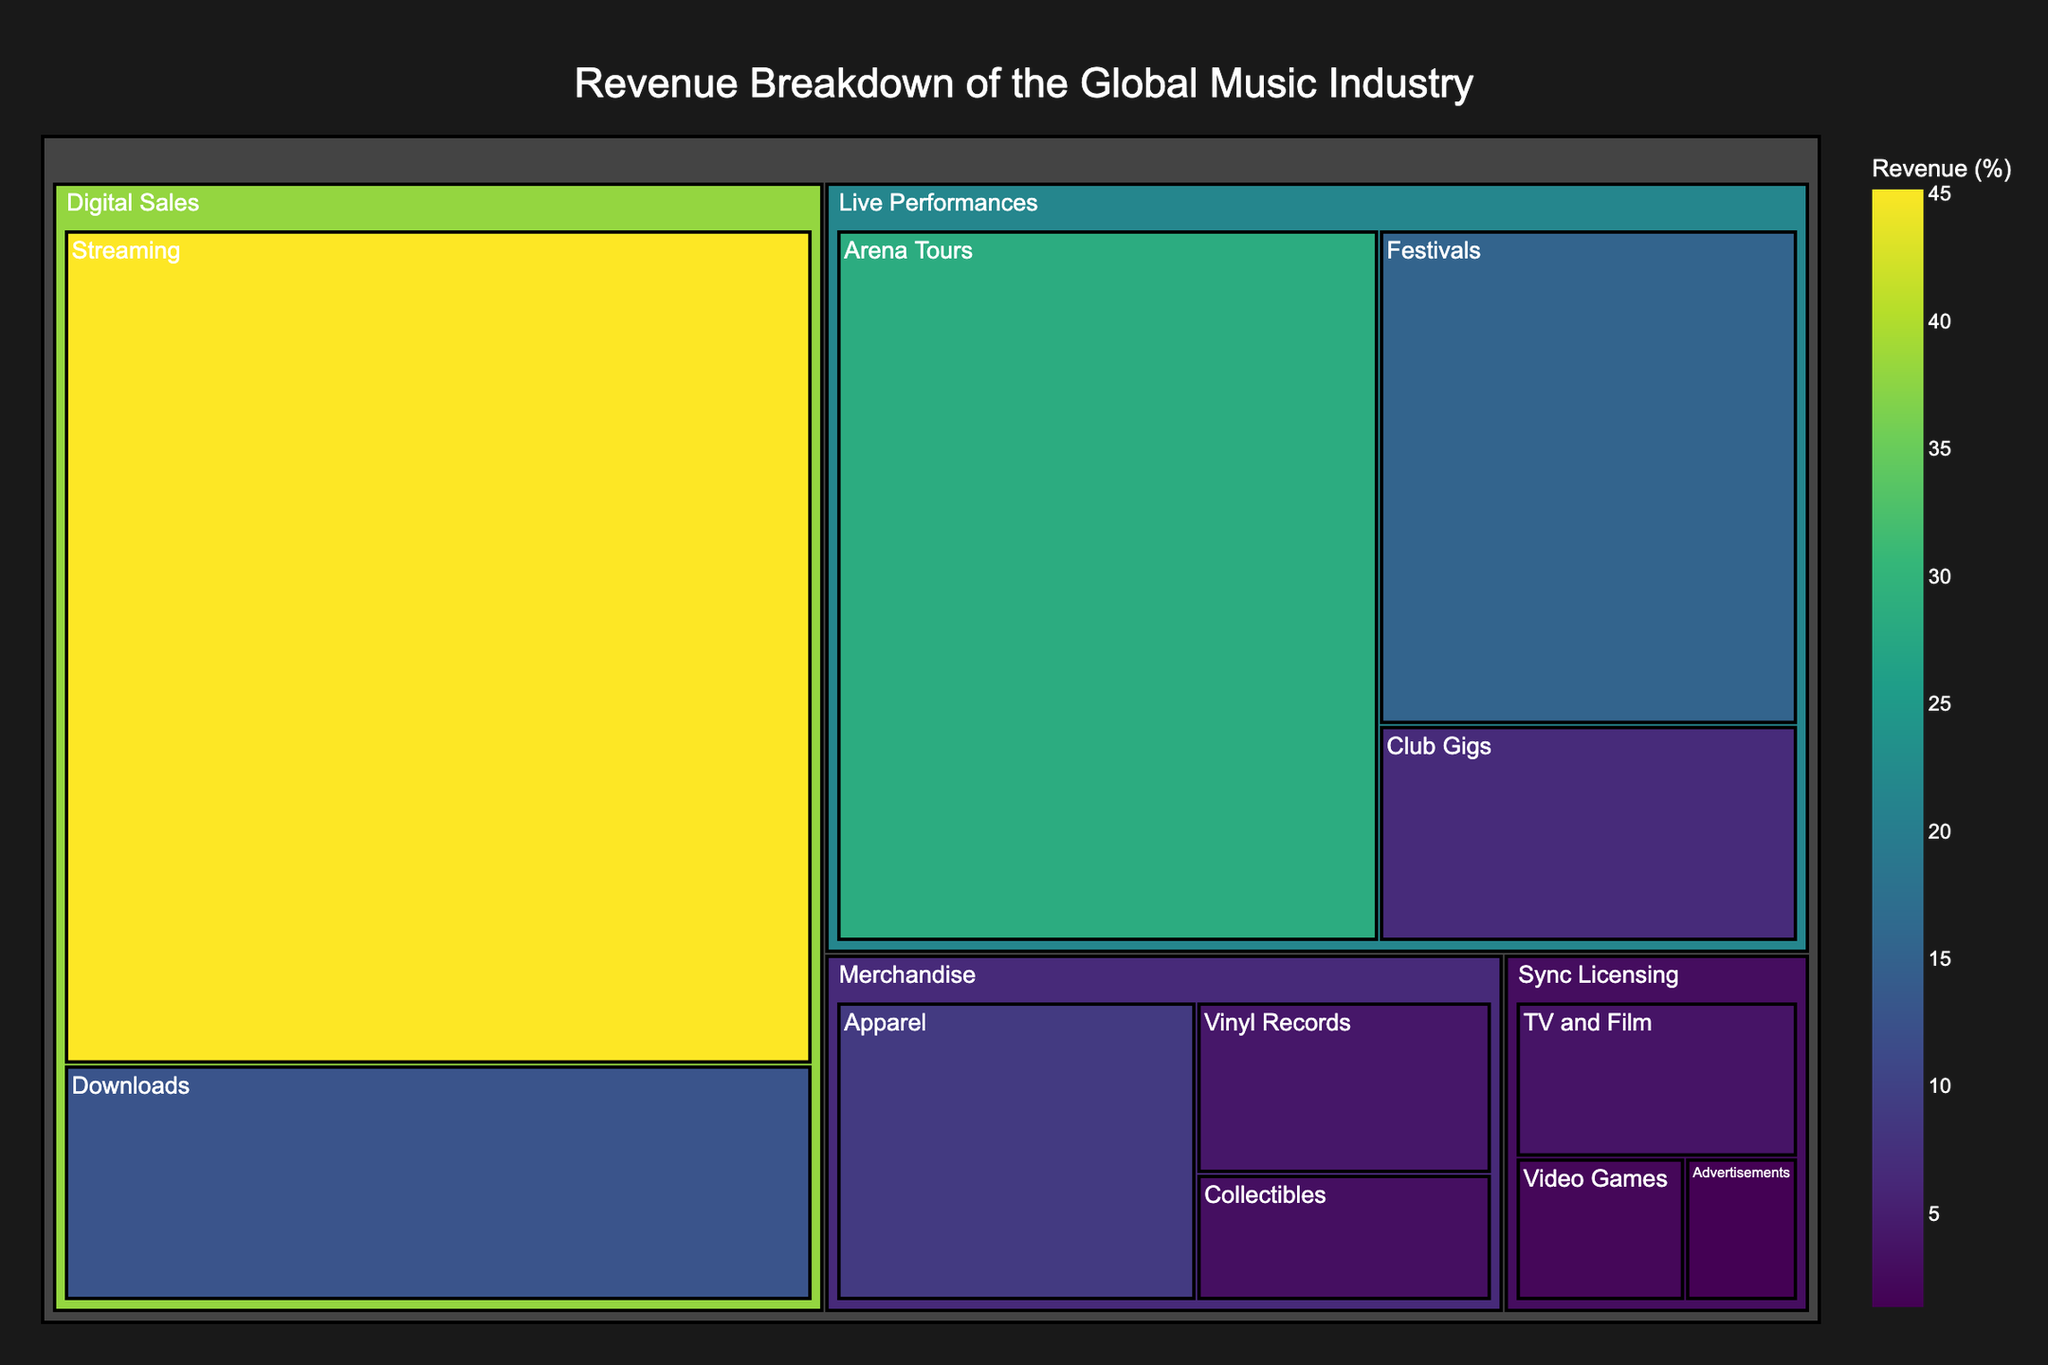what is the largest subcategory in terms of value? The largest subcategory in terms of value can be identified by looking at the size of the sections within the treemap. The section labeled "Streaming" under "Digital Sales" appears to be the largest.
Answer: Streaming what is the total value of the Live Performances category? To find the total value of the Live Performances category, sum the values of the subcategories: Arena Tours (28.5), Festivals (15.3), and Club Gigs (6.7). The calculation is 28.5 + 15.3 + 6.7 = 50.5.
Answer: 50.5 Which is greater: the value of Digital Sales or Live Performances? To determine which is greater, sum the values of the subcategories for each category. Digital Sales has 45.2 (Streaming) + 12.8 (Downloads) = 58. Live Performances has 28.5 (Arena Tours) + 15.3 (Festivals) + 6.7 (Club Gigs) = 50.5. Since 58 > 50.5, Digital Sales is greater.
Answer: Digital Sales What is the difference in value between the largest and smallest subcategories? To find the difference, identify the largest subcategory (Streaming at 45.2) and the smallest subcategory (Advertisements at 1.4), then subtract the smallest from the largest: 45.2 - 1.4 = 43.8.
Answer: 43.8 How does the value of Apparel in Merchandise compare with the value of Arena Tours in Live Performances? Compare the values of these subcategories: Apparel (8.9) and Arena Tours (28.5). Since 28.5 > 8.9, Arena Tours has a greater value.
Answer: Arena Tours What's the total value of all subcategories under Sync Licensing? Sum the values of the subcategories under Sync Licensing: TV and Film (3.8), Video Games (2.1), Advertisements (1.4). The calculation is 3.8 + 2.1 + 1.4 = 7.3.
Answer: 7.3 What is the smallest subcategory value in Merchandise? The smallest subcategory in Merchandise can be found by comparing the values: Apparel (8.9), Vinyl Records (4.2), Collectibles (3.1). The smallest value is 3.1 for Collectibles.
Answer: Collectibles Which category has the least total value? To find the category with the least total value, sum up the subcategory values within each category and compare. Digital Sales has 58, Live Performances has 50.5, Merchandise has 16.2 (8.9 + 4.2 + 3.1), and Sync Licensing has 7.3. Sync Licensing is the smallest with a total of 7.3.
Answer: Sync Licensing What percentage of the total value does the Streaming subcategory represent? To find the percentage, first compute the total value of all subcategories: 45.2 + 12.8 + 28.5 + 15.3 + 6.7 + 8.9 + 4.2 + 3.1 + 3.8 + 2.1 + 1.4 = 132. To find the percentage represented by Streaming, divide its value (45.2) by the total (132) and multiply by 100: (45.2 / 132) * 100 ≈ 34.24%.
Answer: 34.24% How many subcategories are there in total in the figure? Count the total number of subcategories provided across all categories: Streaming, Downloads, Arena Tours, Festivals, Club Gigs, Apparel, Vinyl Records, Collectibles, TV and Film, Video Games, Advertisements. There are 11 subcategories in total.
Answer: 11 